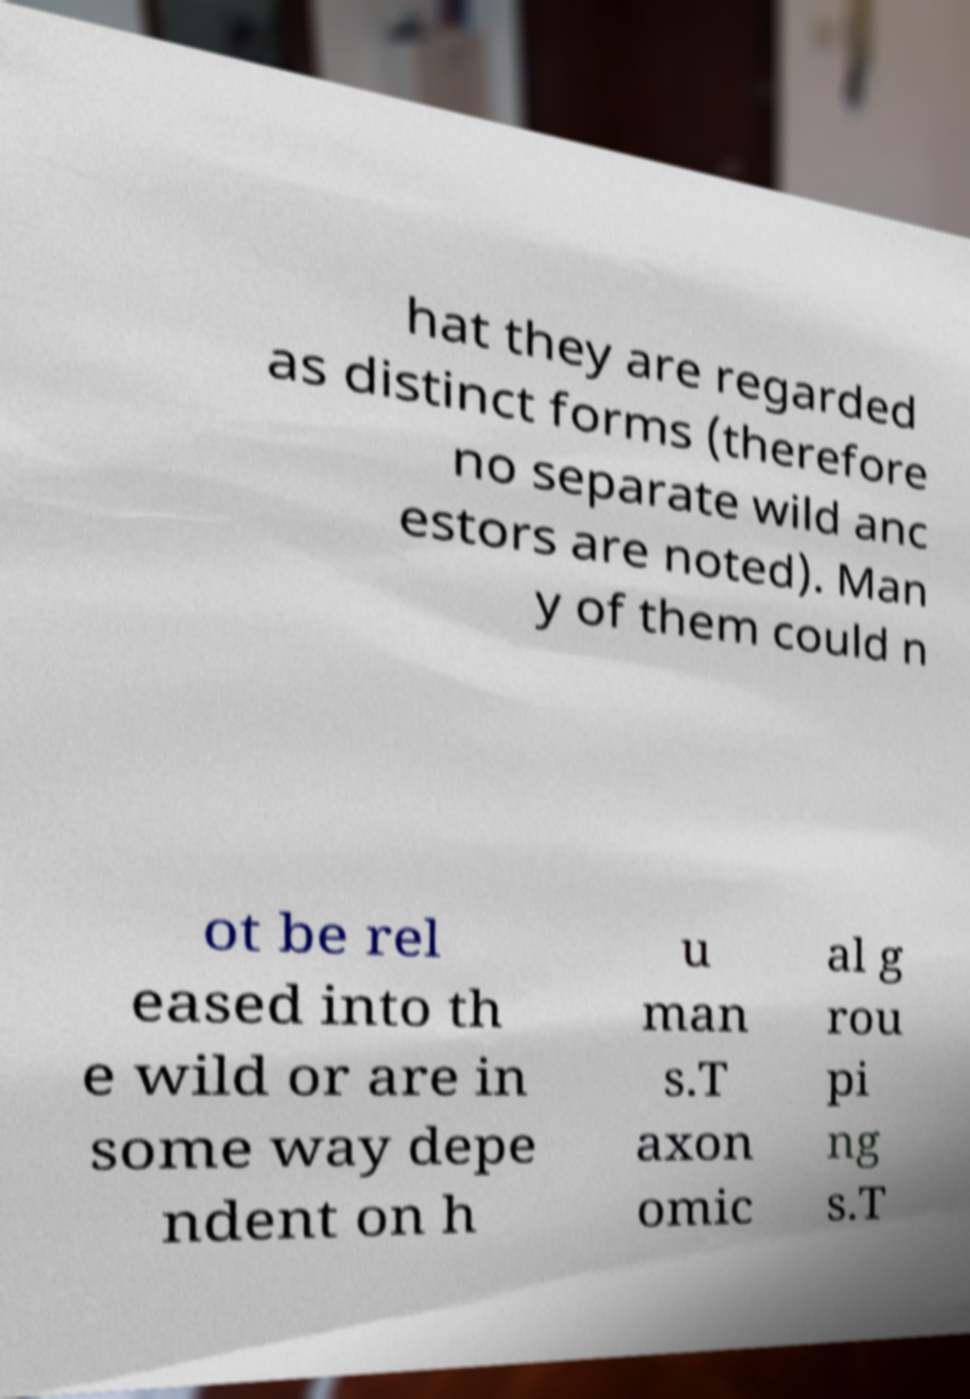I need the written content from this picture converted into text. Can you do that? hat they are regarded as distinct forms (therefore no separate wild anc estors are noted). Man y of them could n ot be rel eased into th e wild or are in some way depe ndent on h u man s.T axon omic al g rou pi ng s.T 